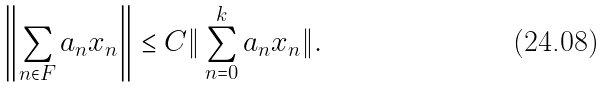<formula> <loc_0><loc_0><loc_500><loc_500>\left \| \sum _ { n \in F } a _ { n } x _ { n } \right \| \leq C \| \sum _ { n = 0 } ^ { k } a _ { n } x _ { n } \| .</formula> 